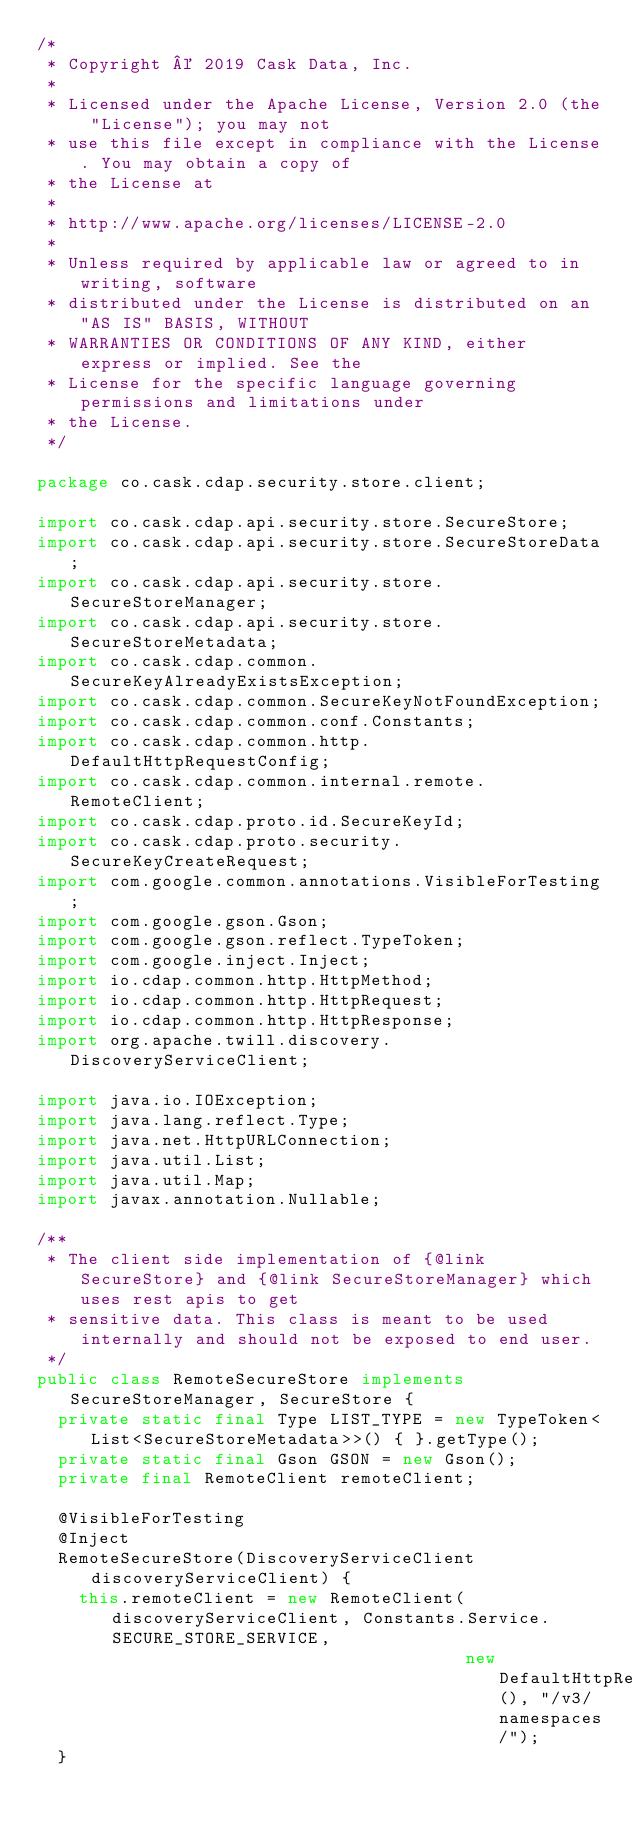<code> <loc_0><loc_0><loc_500><loc_500><_Java_>/*
 * Copyright © 2019 Cask Data, Inc.
 *
 * Licensed under the Apache License, Version 2.0 (the "License"); you may not
 * use this file except in compliance with the License. You may obtain a copy of
 * the License at
 *
 * http://www.apache.org/licenses/LICENSE-2.0
 *
 * Unless required by applicable law or agreed to in writing, software
 * distributed under the License is distributed on an "AS IS" BASIS, WITHOUT
 * WARRANTIES OR CONDITIONS OF ANY KIND, either express or implied. See the
 * License for the specific language governing permissions and limitations under
 * the License.
 */

package co.cask.cdap.security.store.client;

import co.cask.cdap.api.security.store.SecureStore;
import co.cask.cdap.api.security.store.SecureStoreData;
import co.cask.cdap.api.security.store.SecureStoreManager;
import co.cask.cdap.api.security.store.SecureStoreMetadata;
import co.cask.cdap.common.SecureKeyAlreadyExistsException;
import co.cask.cdap.common.SecureKeyNotFoundException;
import co.cask.cdap.common.conf.Constants;
import co.cask.cdap.common.http.DefaultHttpRequestConfig;
import co.cask.cdap.common.internal.remote.RemoteClient;
import co.cask.cdap.proto.id.SecureKeyId;
import co.cask.cdap.proto.security.SecureKeyCreateRequest;
import com.google.common.annotations.VisibleForTesting;
import com.google.gson.Gson;
import com.google.gson.reflect.TypeToken;
import com.google.inject.Inject;
import io.cdap.common.http.HttpMethod;
import io.cdap.common.http.HttpRequest;
import io.cdap.common.http.HttpResponse;
import org.apache.twill.discovery.DiscoveryServiceClient;

import java.io.IOException;
import java.lang.reflect.Type;
import java.net.HttpURLConnection;
import java.util.List;
import java.util.Map;
import javax.annotation.Nullable;

/**
 * The client side implementation of {@link SecureStore} and {@link SecureStoreManager} which uses rest apis to get
 * sensitive data. This class is meant to be used internally and should not be exposed to end user.
 */
public class RemoteSecureStore implements SecureStoreManager, SecureStore {
  private static final Type LIST_TYPE = new TypeToken<List<SecureStoreMetadata>>() { }.getType();
  private static final Gson GSON = new Gson();
  private final RemoteClient remoteClient;

  @VisibleForTesting
  @Inject
  RemoteSecureStore(DiscoveryServiceClient discoveryServiceClient) {
    this.remoteClient = new RemoteClient(discoveryServiceClient, Constants.Service.SECURE_STORE_SERVICE,
                                         new DefaultHttpRequestConfig(), "/v3/namespaces/");
  }
</code> 